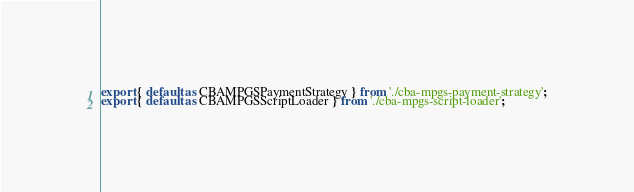<code> <loc_0><loc_0><loc_500><loc_500><_TypeScript_>export { default as CBAMPGSPaymentStrategy } from './cba-mpgs-payment-strategy';
export { default as CBAMPGSScriptLoader } from './cba-mpgs-script-loader';
</code> 